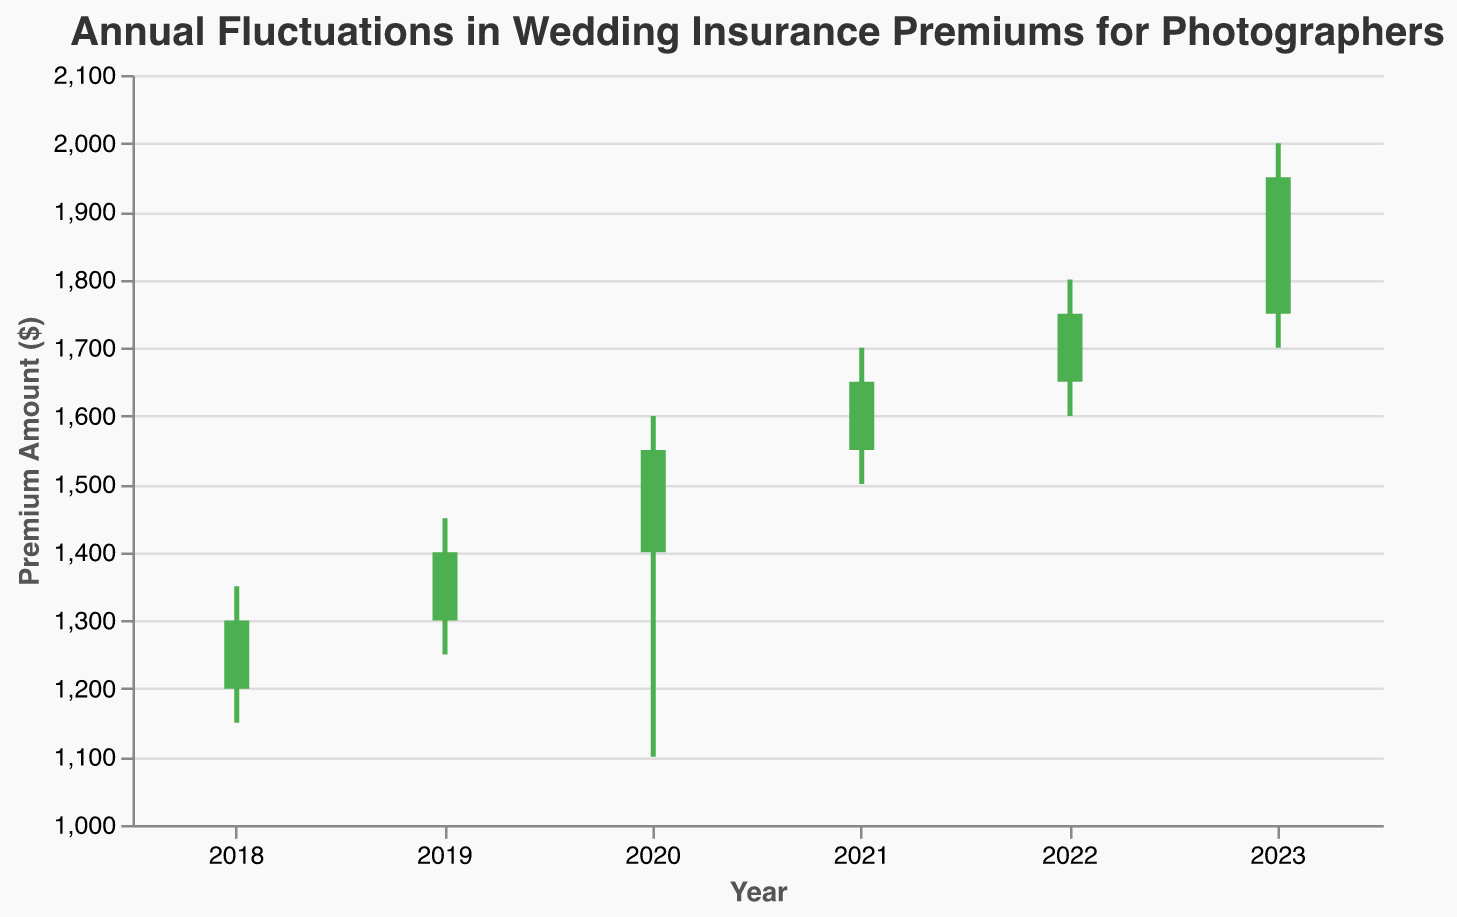What is the title of the chart? The title of the chart is at the top and usually describes the main topic of the data visualization.
Answer: Annual Fluctuations in Wedding Insurance Premiums for Photographers What is the highest premium amount recorded in the data? Look for the highest point on the "High" y-axis values. According to the chart, the highest premium amount for any year is recorded in 2023, where it reached 2000.
Answer: 2000 How did the premium amount change from 2018 to 2019? Compare the "Open" amount in 2018 with the "Close" amount in 2019. In 2018, the premium opened at 1200 and in 2019 it closed at 1400, indicating an increase.
Answer: Increased Which year experienced the largest difference between its high and low values? Calculate the difference between the "High" and "Low" amounts for each year, and find the year with the largest difference. 2020 had a high of 1600 and a low of 1100, a difference of 500, the largest among all years.
Answer: 2020 For which years was the closing premium amount higher than the opening premium amount? Compare "Open" and "Close" values for each year. 2018 (1200 < 1300), 2019 (1300 < 1400), 2020 (1400 < 1550), 2021 (1550 < 1650), 2022 (1650 < 1750), 2023 (1750 < 1950) all have closing amounts higher than their corresponding opening amounts.
Answer: 2018, 2019, 2020, 2021, 2022, 2023 What is the average closing premium amount from 2018 to 2023? (1300 + 1400 + 1550 + 1650 + 1750 + 1950) / 6 = 9600 / 6
Answer: 1600 Compare the opening premium of 2019 and the closing premium of 2020. Which one is higher? The opening premium of 2019 is 1300, and the closing premium of 2020 is 1550. The closing premium of 2020 is higher.
Answer: The closing premium of 2020 Was there any year where the opening and closing premiums were the same? Review the "Open" and "Close" values for all years. None of the years have equal opening and closing values.
Answer: No Which year saw the smallest increase in premium from open to close? Calculate the difference between "Open" and "Close" for each year. 2018 had an increase of 100 (1300 - 1200), which is the smallest increase.
Answer: 2018 From which year to which year did the biggest increase in the closing premium happen? Look for the largest increase in "Close" values year-over-year. The largest increase is from 2022 (1750) to 2023 (1950), an increase of 200.
Answer: From 2022 to 2023 